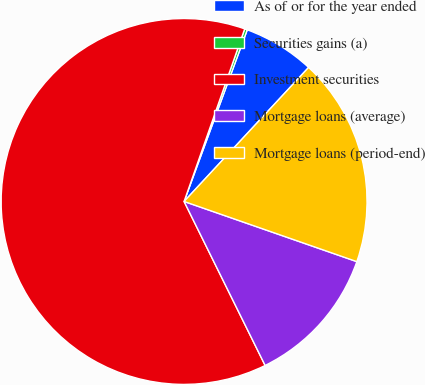Convert chart. <chart><loc_0><loc_0><loc_500><loc_500><pie_chart><fcel>As of or for the year ended<fcel>Securities gains (a)<fcel>Investment securities<fcel>Mortgage loans (average)<fcel>Mortgage loans (period-end)<nl><fcel>6.3%<fcel>0.24%<fcel>62.68%<fcel>12.36%<fcel>18.42%<nl></chart> 